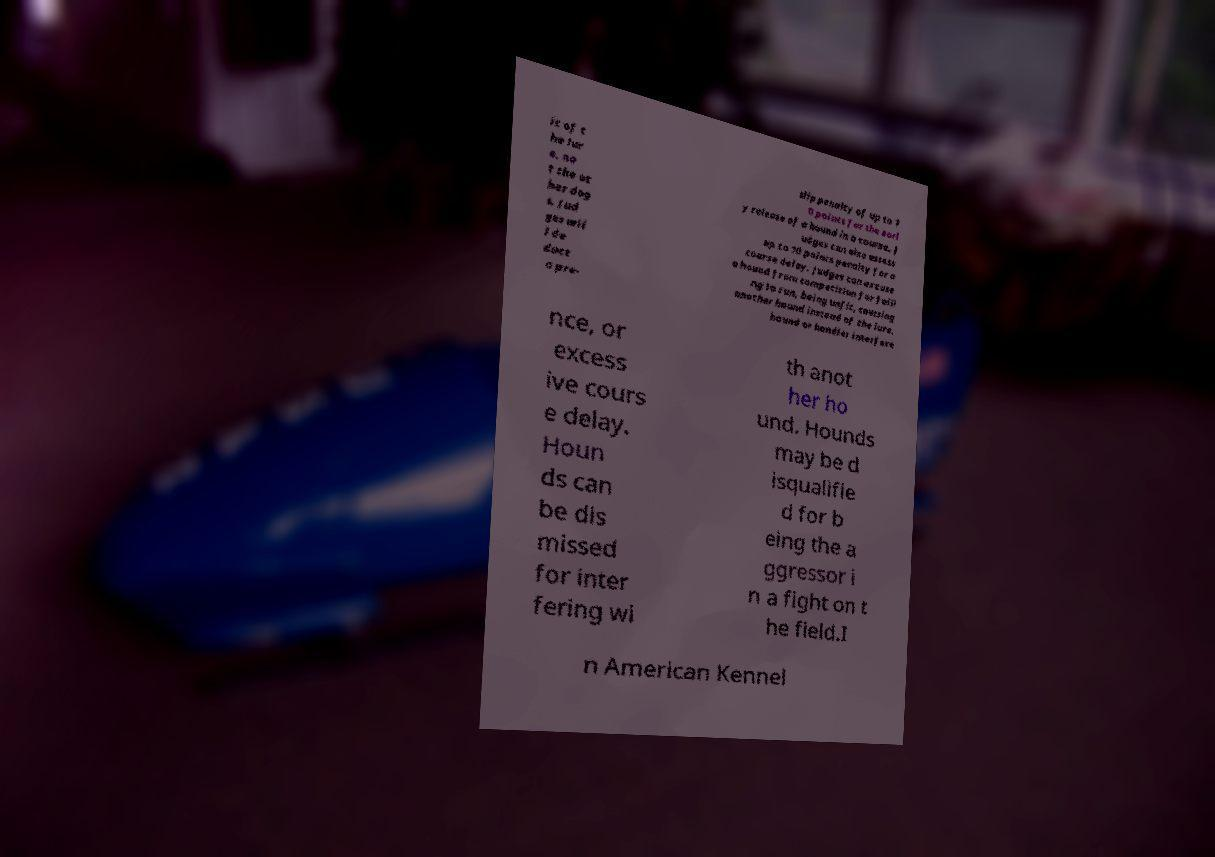Please identify and transcribe the text found in this image. it of t he lur e, no t the ot her dog s. Jud ges wil l de duct a pre- slip penalty of up to 1 0 points for the earl y release of a hound in a course. J udges can also assess up to 10 points penalty for a course delay. Judges can excuse a hound from competition for faili ng to run, being unfit, coursing another hound instead of the lure, hound or handler interfere nce, or excess ive cours e delay. Houn ds can be dis missed for inter fering wi th anot her ho und. Hounds may be d isqualifie d for b eing the a ggressor i n a fight on t he field.I n American Kennel 